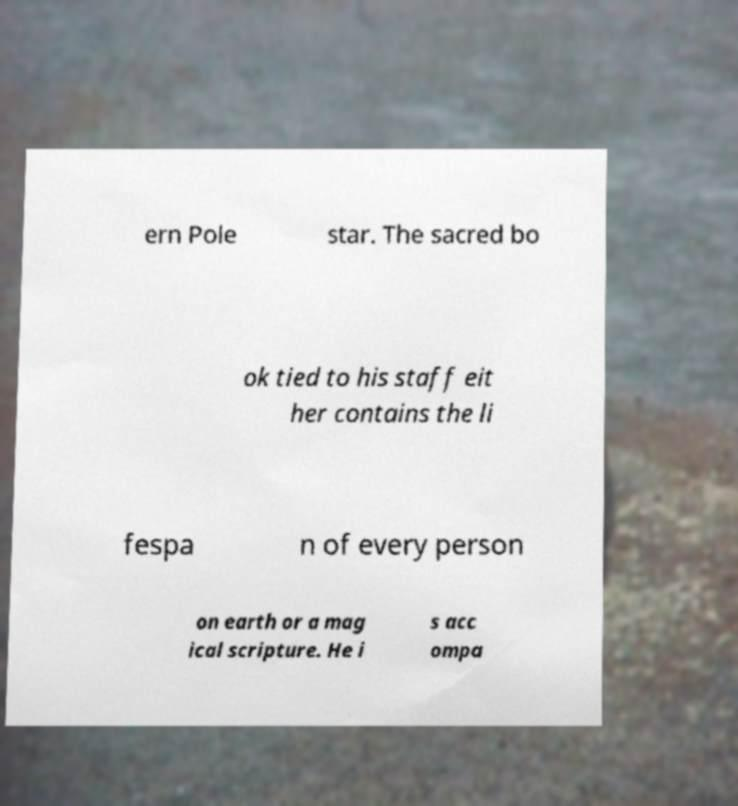Could you extract and type out the text from this image? ern Pole star. The sacred bo ok tied to his staff eit her contains the li fespa n of every person on earth or a mag ical scripture. He i s acc ompa 